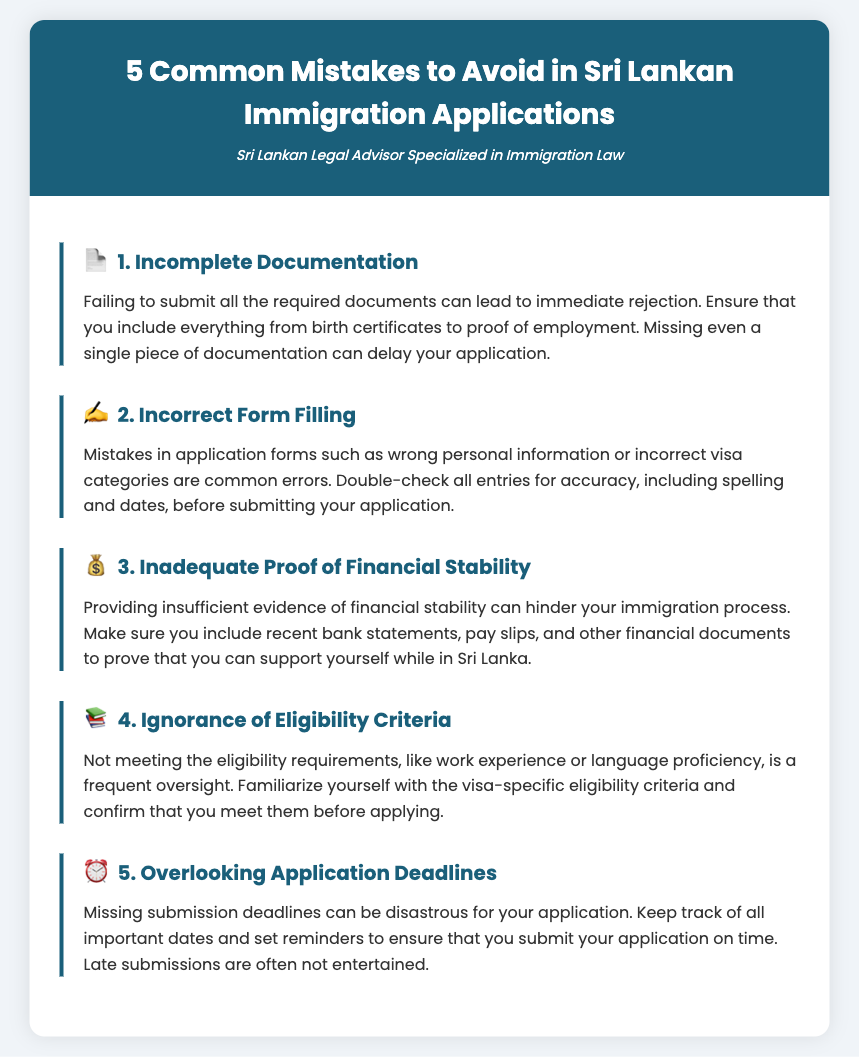What is the first common mistake to avoid? The first mistake listed is "Incomplete Documentation."
Answer: Incomplete Documentation How many common mistakes are listed in total? The document outlines a total of five common mistakes.
Answer: 5 What should you ensure to include for the first mistake? For the first mistake, it is advised to include all required documents such as birth certificates and proof of employment.
Answer: All required documents Which financial documents are necessary to demonstrate stability? The document mentions providing recent bank statements, pay slips, and other financial documents.
Answer: Recent bank statements, pay slips, financial documents What is emphasized for filling application forms? It is emphasized to double-check all entries for accuracy, including spelling and dates.
Answer: Double-check all entries for accuracy What can lead to the rejection of your application? Missing even a single piece of documentation can lead to rejection.
Answer: Missing a single piece of documentation What is a frequent oversight in determining eligibility? A frequent oversight is not meeting the eligibility requirements, such as work experience or language proficiency.
Answer: Not meeting eligibility requirements What is advised regarding application deadlines? The document advises keeping track of all important dates and setting reminders to ensure timely submission.
Answer: Keep track of all important dates What are the common mistakes categorized under? The common mistakes are categorized under immigration applications in Sri Lanka.
Answer: Immigration applications 